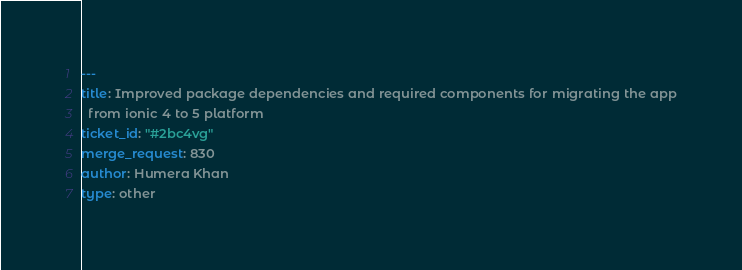<code> <loc_0><loc_0><loc_500><loc_500><_YAML_>---
title: Improved package dependencies and required components for migrating the app
  from ionic 4 to 5 platform
ticket_id: "#2bc4vg"
merge_request: 830
author: Humera Khan
type: other
</code> 